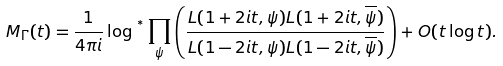<formula> <loc_0><loc_0><loc_500><loc_500>M _ { \Gamma } ( t ) = \frac { 1 } { 4 \pi i } \log { ^ { ^ { * } } } \prod _ { \psi } \left ( \frac { L ( 1 + 2 i t , \psi ) L ( 1 + 2 i t , \overline { \psi } ) } { L ( 1 - 2 i t , \psi ) L ( 1 - 2 i t , \overline { \psi } ) } \right ) + O ( t \log t ) .</formula> 